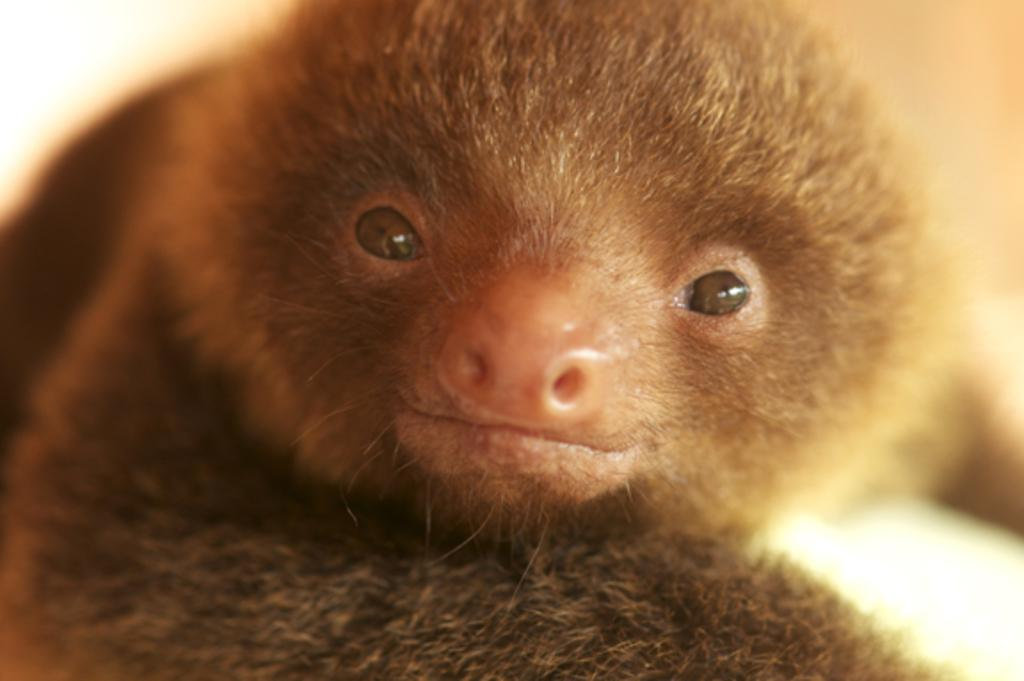What type of creature is present in the image? There is an animal in the image. Can you describe the color of the animal? The animal is brown in color. What can be observed about the background of the image? The background of the image is blurred. What type of education does the cheese in the image have? There is no cheese present in the image, so it cannot have any education. 